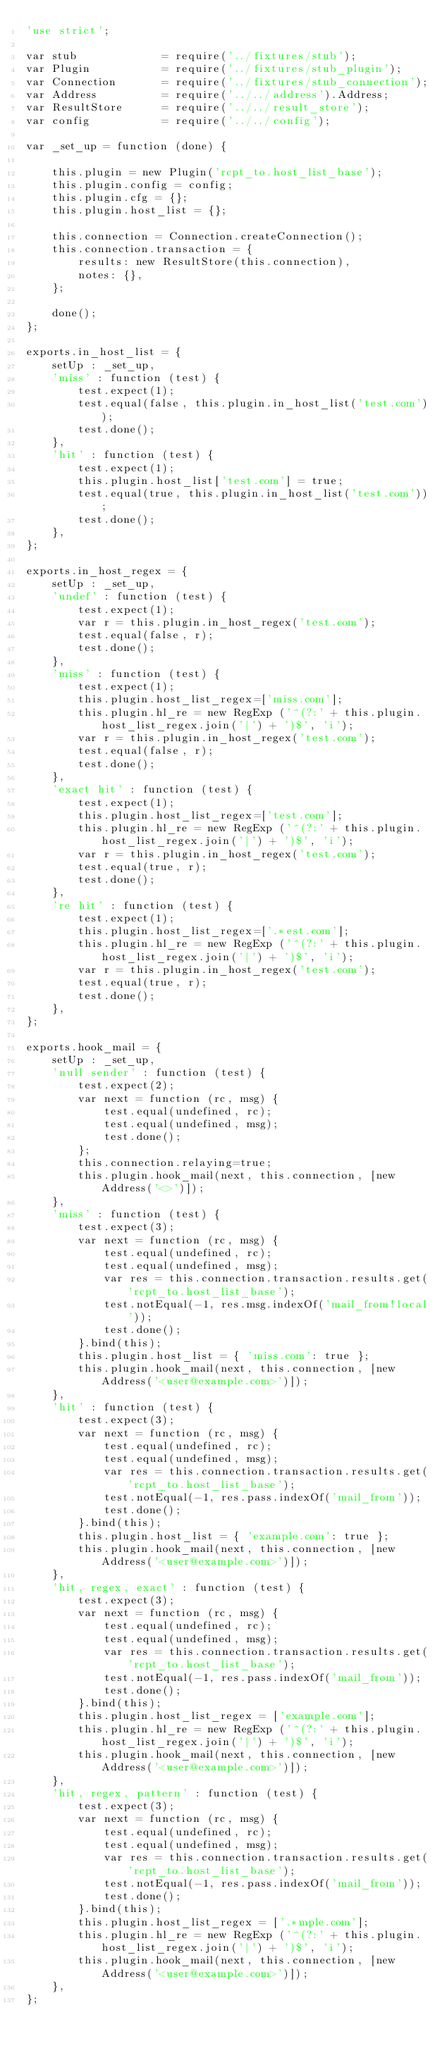<code> <loc_0><loc_0><loc_500><loc_500><_JavaScript_>'use strict';

var stub             = require('../fixtures/stub');
var Plugin           = require('../fixtures/stub_plugin');
var Connection       = require('../fixtures/stub_connection');
var Address          = require('../../address').Address;
var ResultStore      = require('../../result_store');
var config           = require('../../config');

var _set_up = function (done) {

    this.plugin = new Plugin('rcpt_to.host_list_base');
    this.plugin.config = config;
    this.plugin.cfg = {};
    this.plugin.host_list = {};

    this.connection = Connection.createConnection();
    this.connection.transaction = {
        results: new ResultStore(this.connection),
        notes: {},
    };

    done();
};

exports.in_host_list = {
    setUp : _set_up,
    'miss' : function (test) {
        test.expect(1);
        test.equal(false, this.plugin.in_host_list('test.com'));
        test.done();
    },
    'hit' : function (test) {
        test.expect(1);
        this.plugin.host_list['test.com'] = true;
        test.equal(true, this.plugin.in_host_list('test.com'));
        test.done();
    },
};

exports.in_host_regex = {
    setUp : _set_up,
    'undef' : function (test) {
        test.expect(1);
        var r = this.plugin.in_host_regex('test.com');
        test.equal(false, r);
        test.done();
    },
    'miss' : function (test) {
        test.expect(1);
        this.plugin.host_list_regex=['miss.com'];
        this.plugin.hl_re = new RegExp ('^(?:' + this.plugin.host_list_regex.join('|') + ')$', 'i');
        var r = this.plugin.in_host_regex('test.com');
        test.equal(false, r);
        test.done();
    },
    'exact hit' : function (test) {
        test.expect(1);
        this.plugin.host_list_regex=['test.com'];
        this.plugin.hl_re = new RegExp ('^(?:' + this.plugin.host_list_regex.join('|') + ')$', 'i');
        var r = this.plugin.in_host_regex('test.com');
        test.equal(true, r);
        test.done();
    },
    're hit' : function (test) {
        test.expect(1);
        this.plugin.host_list_regex=['.*est.com'];
        this.plugin.hl_re = new RegExp ('^(?:' + this.plugin.host_list_regex.join('|') + ')$', 'i');
        var r = this.plugin.in_host_regex('test.com');
        test.equal(true, r);
        test.done();
    },
};

exports.hook_mail = {
    setUp : _set_up,
    'null sender' : function (test) {
        test.expect(2);
        var next = function (rc, msg) {
            test.equal(undefined, rc);
            test.equal(undefined, msg);
            test.done();
        };
        this.connection.relaying=true;
        this.plugin.hook_mail(next, this.connection, [new Address('<>')]);
    },
    'miss' : function (test) {
        test.expect(3);
        var next = function (rc, msg) {
            test.equal(undefined, rc);
            test.equal(undefined, msg);
            var res = this.connection.transaction.results.get('rcpt_to.host_list_base');
            test.notEqual(-1, res.msg.indexOf('mail_from!local'));
            test.done();
        }.bind(this);
        this.plugin.host_list = { 'miss.com': true };
        this.plugin.hook_mail(next, this.connection, [new Address('<user@example.com>')]);
    },
    'hit' : function (test) {
        test.expect(3);
        var next = function (rc, msg) {
            test.equal(undefined, rc);
            test.equal(undefined, msg);
            var res = this.connection.transaction.results.get('rcpt_to.host_list_base');
            test.notEqual(-1, res.pass.indexOf('mail_from'));
            test.done();
        }.bind(this);
        this.plugin.host_list = { 'example.com': true };
        this.plugin.hook_mail(next, this.connection, [new Address('<user@example.com>')]);
    },
    'hit, regex, exact' : function (test) {
        test.expect(3);
        var next = function (rc, msg) {
            test.equal(undefined, rc);
            test.equal(undefined, msg);
            var res = this.connection.transaction.results.get('rcpt_to.host_list_base');
            test.notEqual(-1, res.pass.indexOf('mail_from'));
            test.done();
        }.bind(this);
        this.plugin.host_list_regex = ['example.com'];
        this.plugin.hl_re = new RegExp ('^(?:' + this.plugin.host_list_regex.join('|') + ')$', 'i');
        this.plugin.hook_mail(next, this.connection, [new Address('<user@example.com>')]);
    },
    'hit, regex, pattern' : function (test) {
        test.expect(3);
        var next = function (rc, msg) {
            test.equal(undefined, rc);
            test.equal(undefined, msg);
            var res = this.connection.transaction.results.get('rcpt_to.host_list_base');
            test.notEqual(-1, res.pass.indexOf('mail_from'));
            test.done();
        }.bind(this);
        this.plugin.host_list_regex = ['.*mple.com'];
        this.plugin.hl_re = new RegExp ('^(?:' + this.plugin.host_list_regex.join('|') + ')$', 'i');
        this.plugin.hook_mail(next, this.connection, [new Address('<user@example.com>')]);
    },
};
</code> 